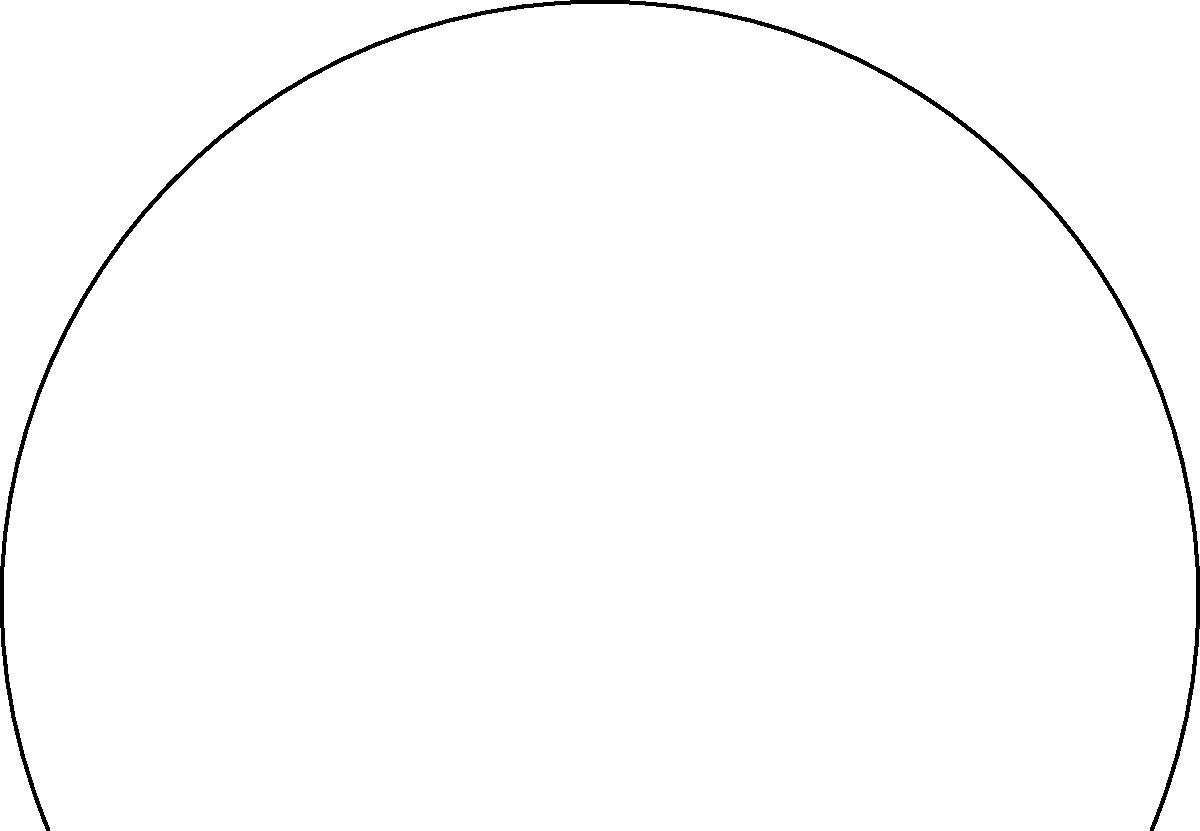In the diagram of the female reproductive system during ovulation, what is the primary function of the structure labeled "Fallopian tube" in relation to the egg released from the ovary? To understand the function of the Fallopian tube during ovulation, let's break down the process:

1. Ovulation: The ovary releases a mature egg (oocyte) from a follicle.
2. Egg pickup: The fimbriae, finger-like projections at the end of the Fallopian tube, sweep the released egg into the tube.
3. Transport: The Fallopian tube serves as a conduit for the egg to travel towards the uterus.
4. Fertilization site: If sperm are present, fertilization typically occurs in the Fallopian tube.
5. Early development: The fertilized egg (zygote) begins to divide and develop as it moves through the tube.
6. Uterine entry: The developing embryo enters the uterus for implantation after about 3-5 days.

The primary function of the Fallopian tube is to provide a pathway for the egg to travel from the ovary to the uterus, while also serving as the potential site for fertilization and early embryo development.
Answer: Transport egg from ovary to uterus and provide fertilization site 